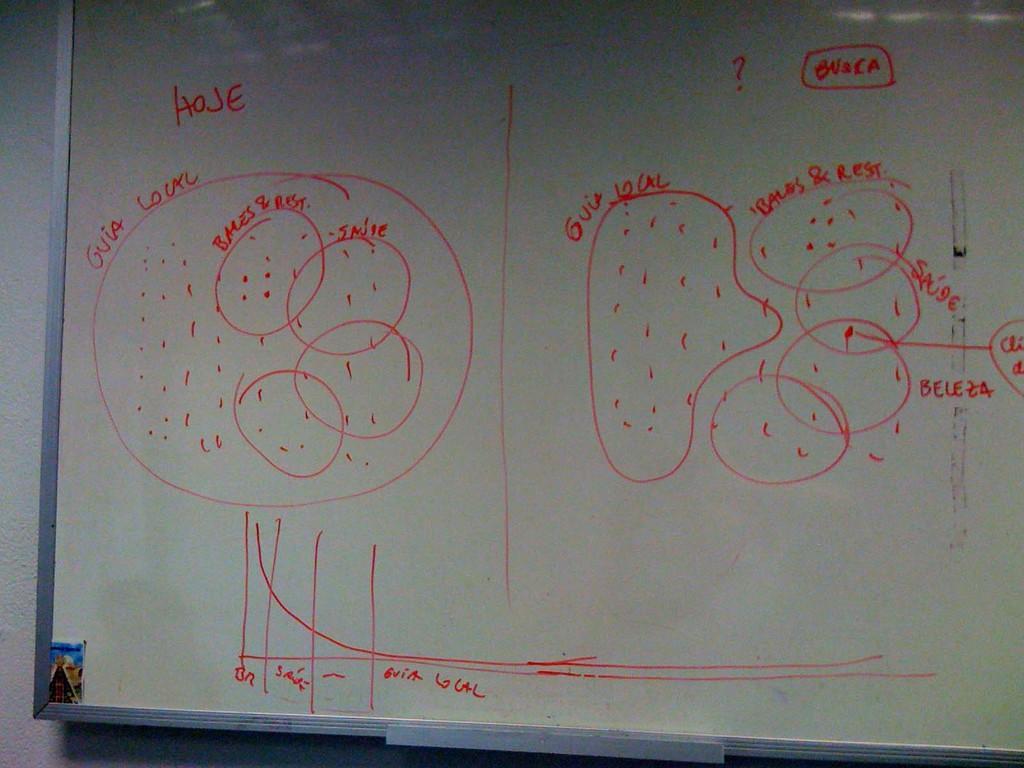Can you describe this image briefly? This picture shows a art on the whiteboard. we see some text and drawing. 